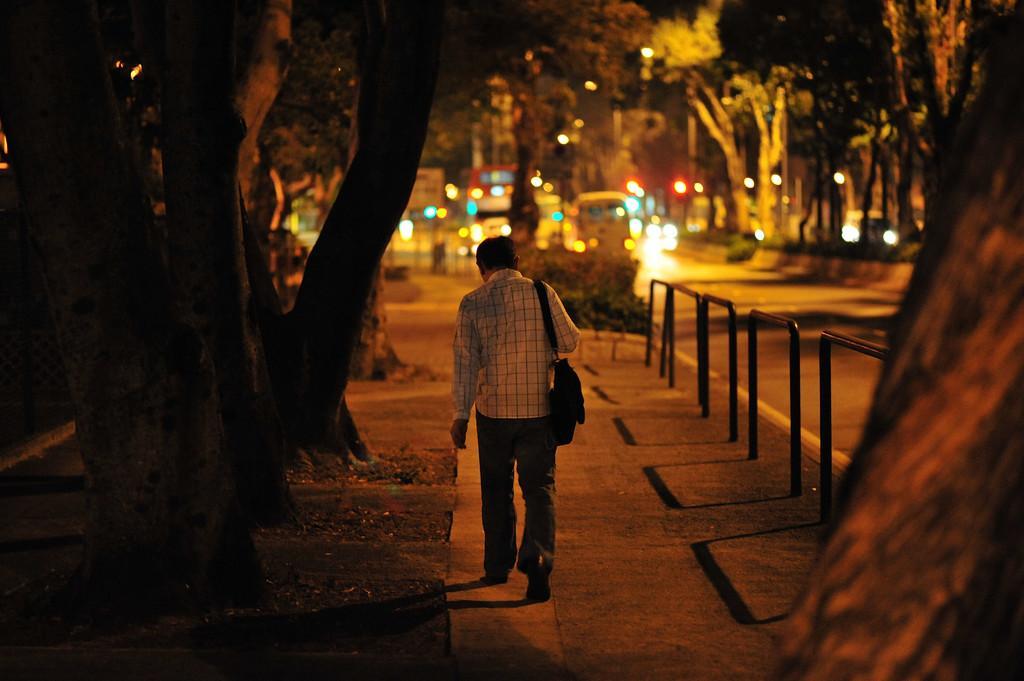Please provide a concise description of this image. In this picture we can see a man is walking on the path and on the right side of man there are iron rods. In front of the man there are some vehicles on the road and trees. 